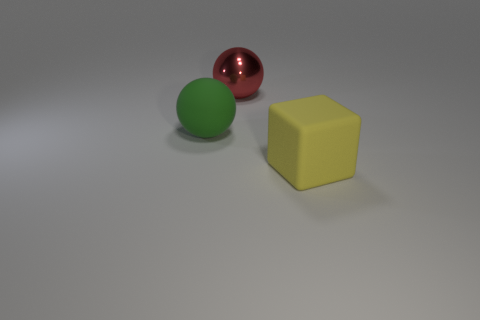What shape is the rubber thing to the left of the large object that is behind the rubber thing behind the yellow rubber block?
Make the answer very short. Sphere. The green rubber ball is what size?
Offer a very short reply. Large. Is there a large object that has the same material as the green sphere?
Provide a succinct answer. Yes. What size is the other thing that is the same shape as the large red object?
Offer a very short reply. Large. Is the number of yellow matte cubes behind the large metallic ball the same as the number of green rubber spheres?
Provide a succinct answer. No. There is a big thing behind the green object; is it the same shape as the big yellow object?
Offer a very short reply. No. What shape is the green rubber object?
Provide a succinct answer. Sphere. What is the material of the big object that is in front of the matte thing left of the block in front of the big rubber ball?
Offer a very short reply. Rubber. What number of objects are spheres or large rubber things?
Offer a very short reply. 3. Do the big block right of the green matte object and the red object have the same material?
Provide a short and direct response. No. 